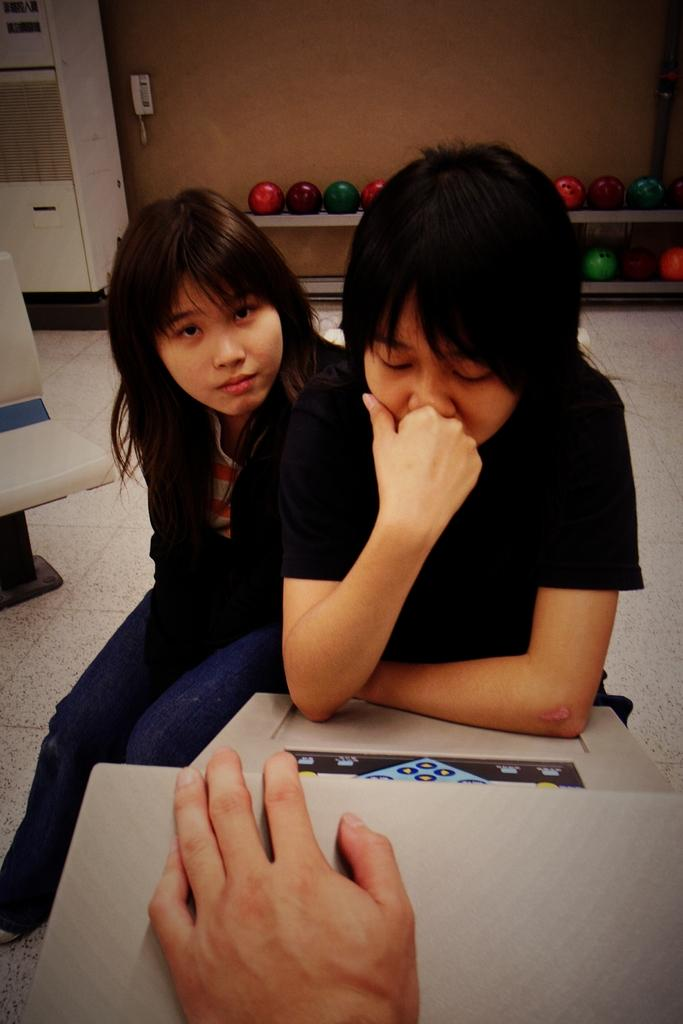How many girls are sitting in the image? There are two girls sitting in the image. What is one of the girls holding? One girl is holding a board. Whose hand is visible in the image? A person's hand is visible in the image. What is behind the girls? There is a chair behind the girls. What else can be seen in the image besides the girls and the chair? There are balls in the image. Where is the market located in the image? There is no market present in the image. What type of drawer can be seen in the image? There is no drawer present in the image. 